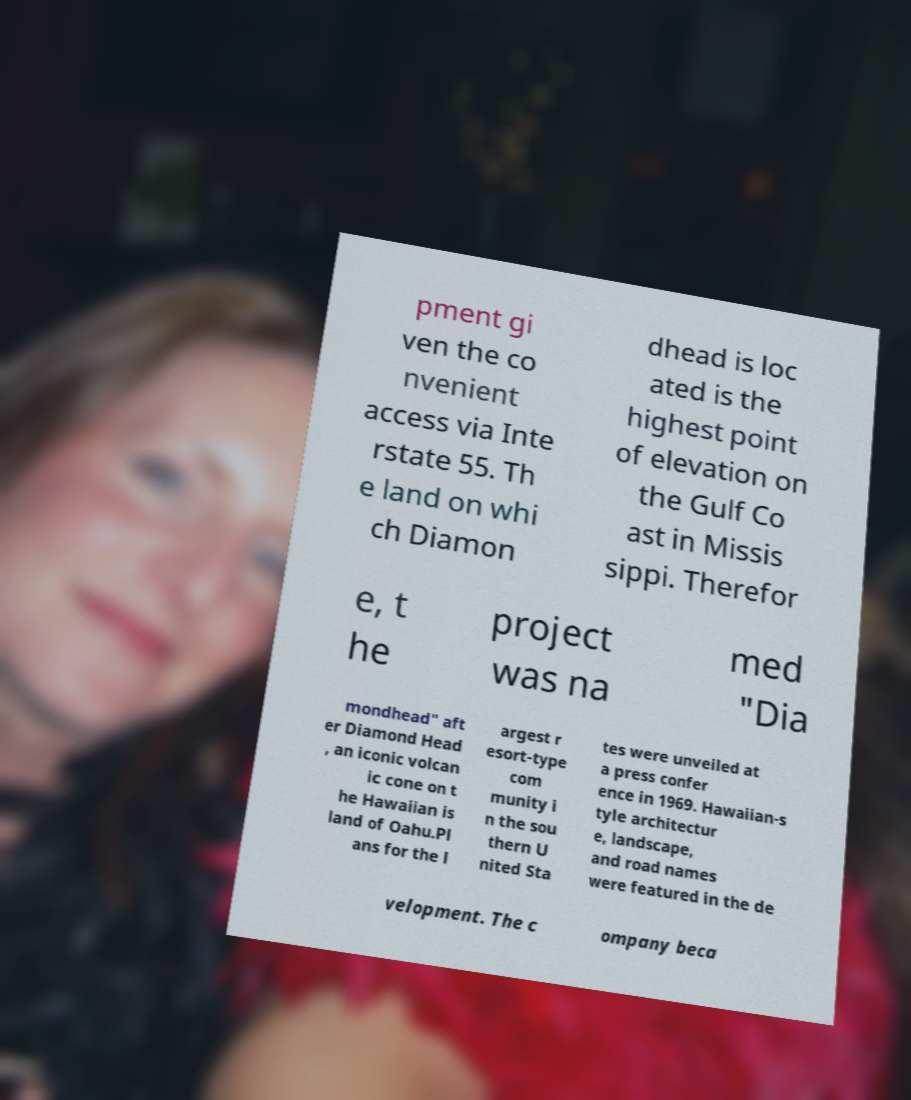Could you assist in decoding the text presented in this image and type it out clearly? pment gi ven the co nvenient access via Inte rstate 55. Th e land on whi ch Diamon dhead is loc ated is the highest point of elevation on the Gulf Co ast in Missis sippi. Therefor e, t he project was na med "Dia mondhead" aft er Diamond Head , an iconic volcan ic cone on t he Hawaiian is land of Oahu.Pl ans for the l argest r esort-type com munity i n the sou thern U nited Sta tes were unveiled at a press confer ence in 1969. Hawaiian-s tyle architectur e, landscape, and road names were featured in the de velopment. The c ompany beca 